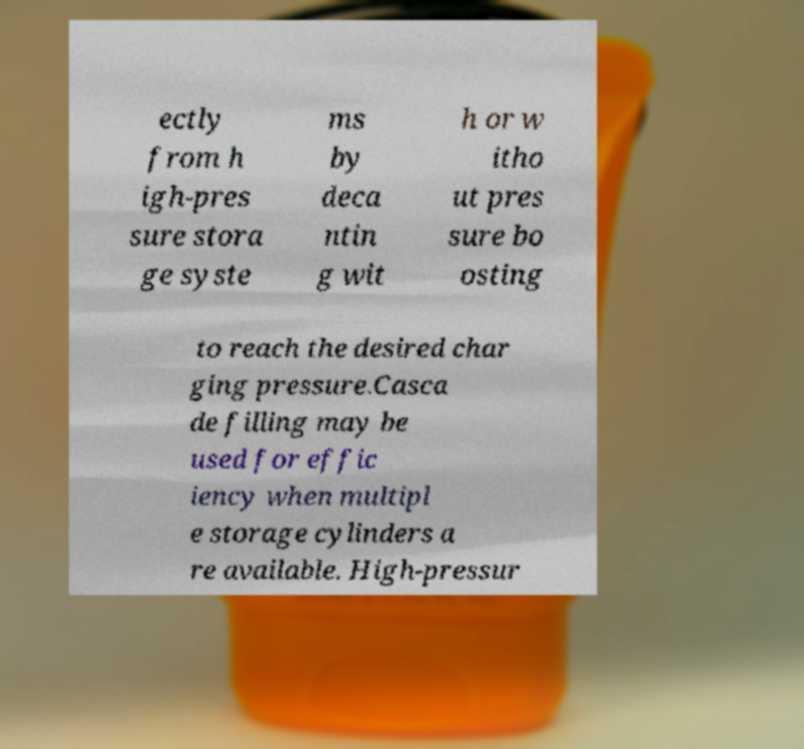There's text embedded in this image that I need extracted. Can you transcribe it verbatim? ectly from h igh-pres sure stora ge syste ms by deca ntin g wit h or w itho ut pres sure bo osting to reach the desired char ging pressure.Casca de filling may be used for effic iency when multipl e storage cylinders a re available. High-pressur 